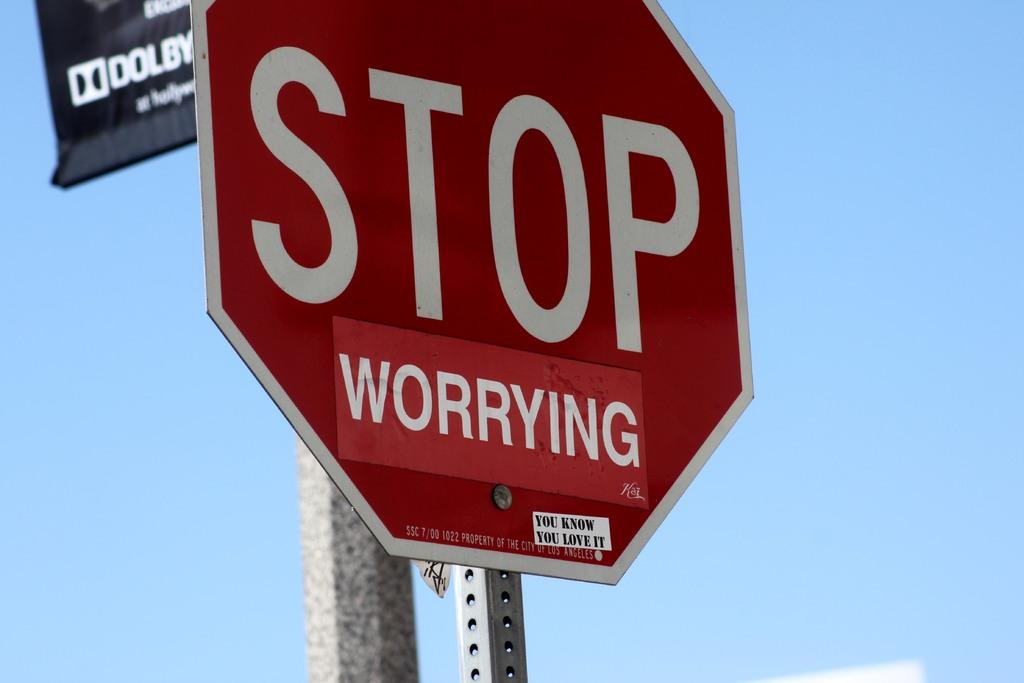Provide a one-sentence caption for the provided image. Due to a sticker being added to the sign, it now reads STOP worrying. 